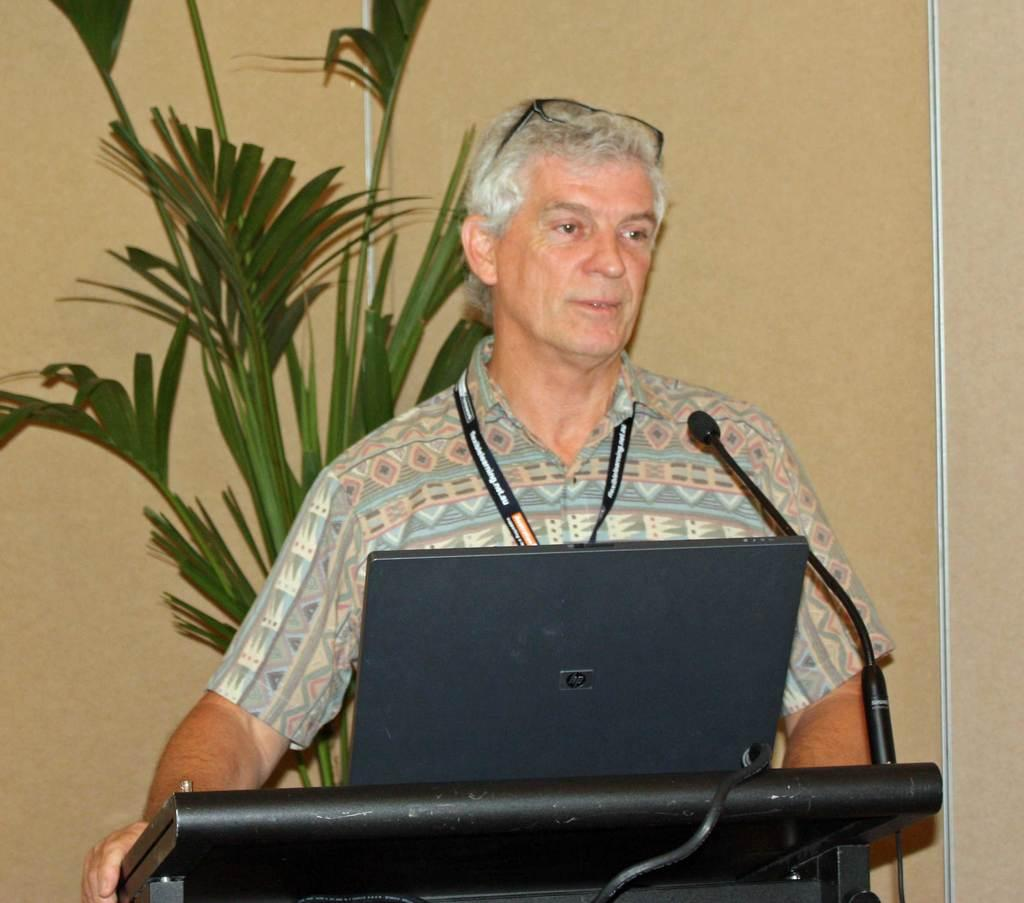What is the man near in the image? The man is standing near the podium in the image. What can be seen on the podium? A laptop and a microphone are present on the podium. What is visible in the background of the image? There is a plant and a wall in the background of the image. What type of popcorn is being served at the event in the image? There is no indication of an event or popcorn being served in the image. 